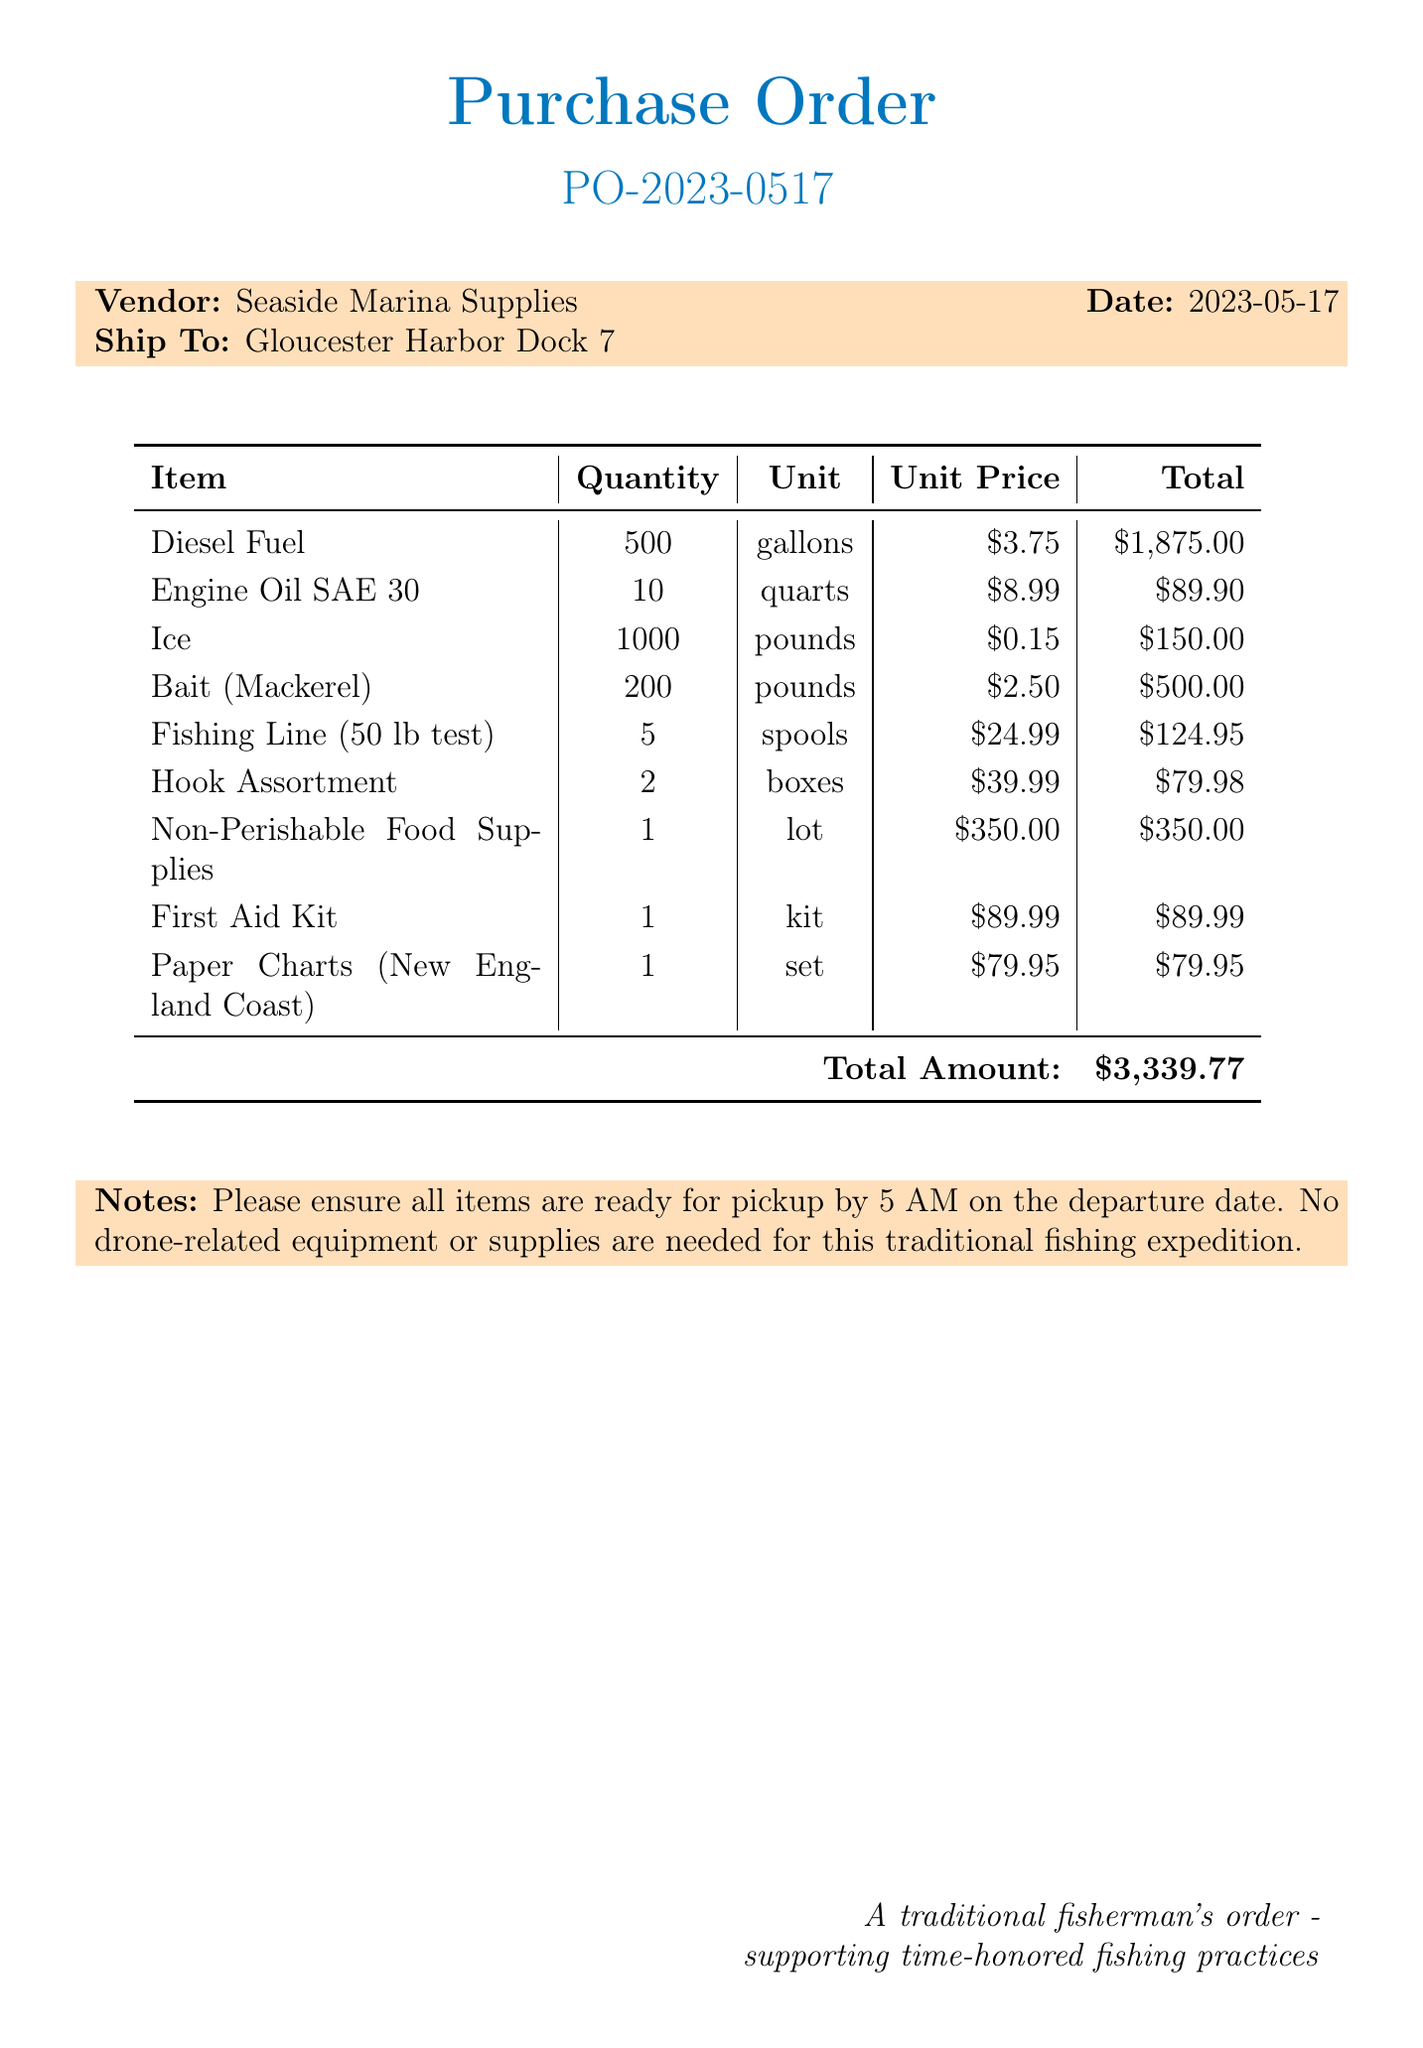What is the order number? The order number is clearly stated in the document for identification purposes.
Answer: PO-2023-0517 Who is the vendor? The vendor's name is specified in the document for supply sourcing.
Answer: Seaside Marina Supplies What is the total amount for the order? The total amount summarizes the costs of all items ordered in the document.
Answer: $3,339.77 How many gallons of diesel fuel are ordered? The quantity of diesel fuel is provided in the itemized list of the purchase order.
Answer: 500 What is the unit price of bait (mackerel)? The unit price for the bait (mackerel) is listed in the order details.
Answer: $2.50 What type of oil is ordered? The specific type of oil is mentioned in the items list.
Answer: Engine Oil SAE 30 What is the date of the purchase order? The date indicates when the purchase order was created, useful for tracking.
Answer: 2023-05-17 What time are the items required for pickup? The pickup time is specified in the notes of the purchase order for planning logistics.
Answer: 5 AM What is noted about drone-related equipment? The notes section emphasizes any exemptions or specifications for the order.
Answer: No drone-related equipment or supplies are needed 